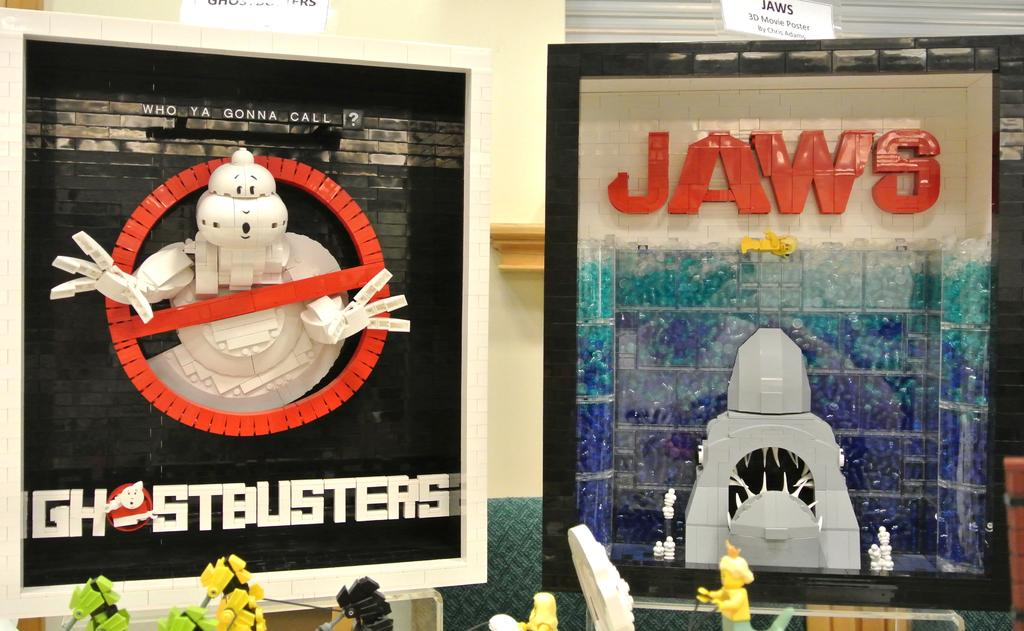What type of objects can be seen in the image? There are colorful objects in the image. Where are the toys located in the image? The toys are at the bottom of the image. What can be seen in the background of the image? There is a wall visible in the background of the image. What is written at the top of the image? There are name boards at the top of the image. What type of argument is taking place in the image? There is no argument present in the image. 